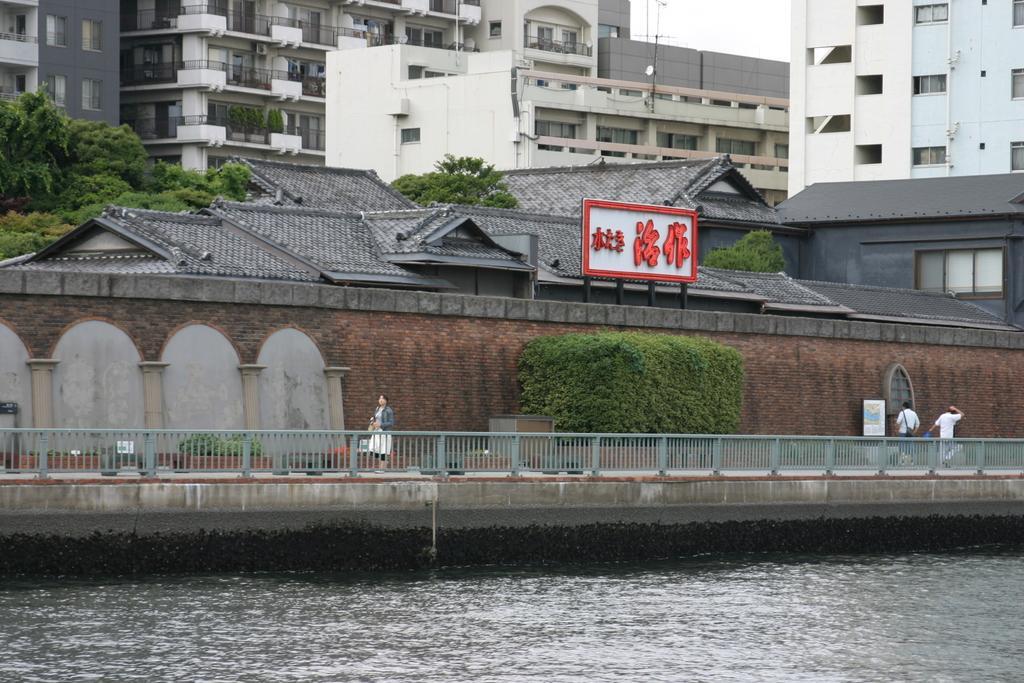In one or two sentences, can you explain what this image depicts? In this image we can see water and a walkway on which there are some persons walking and in the background of the image there are some houses, buildings and trees. 